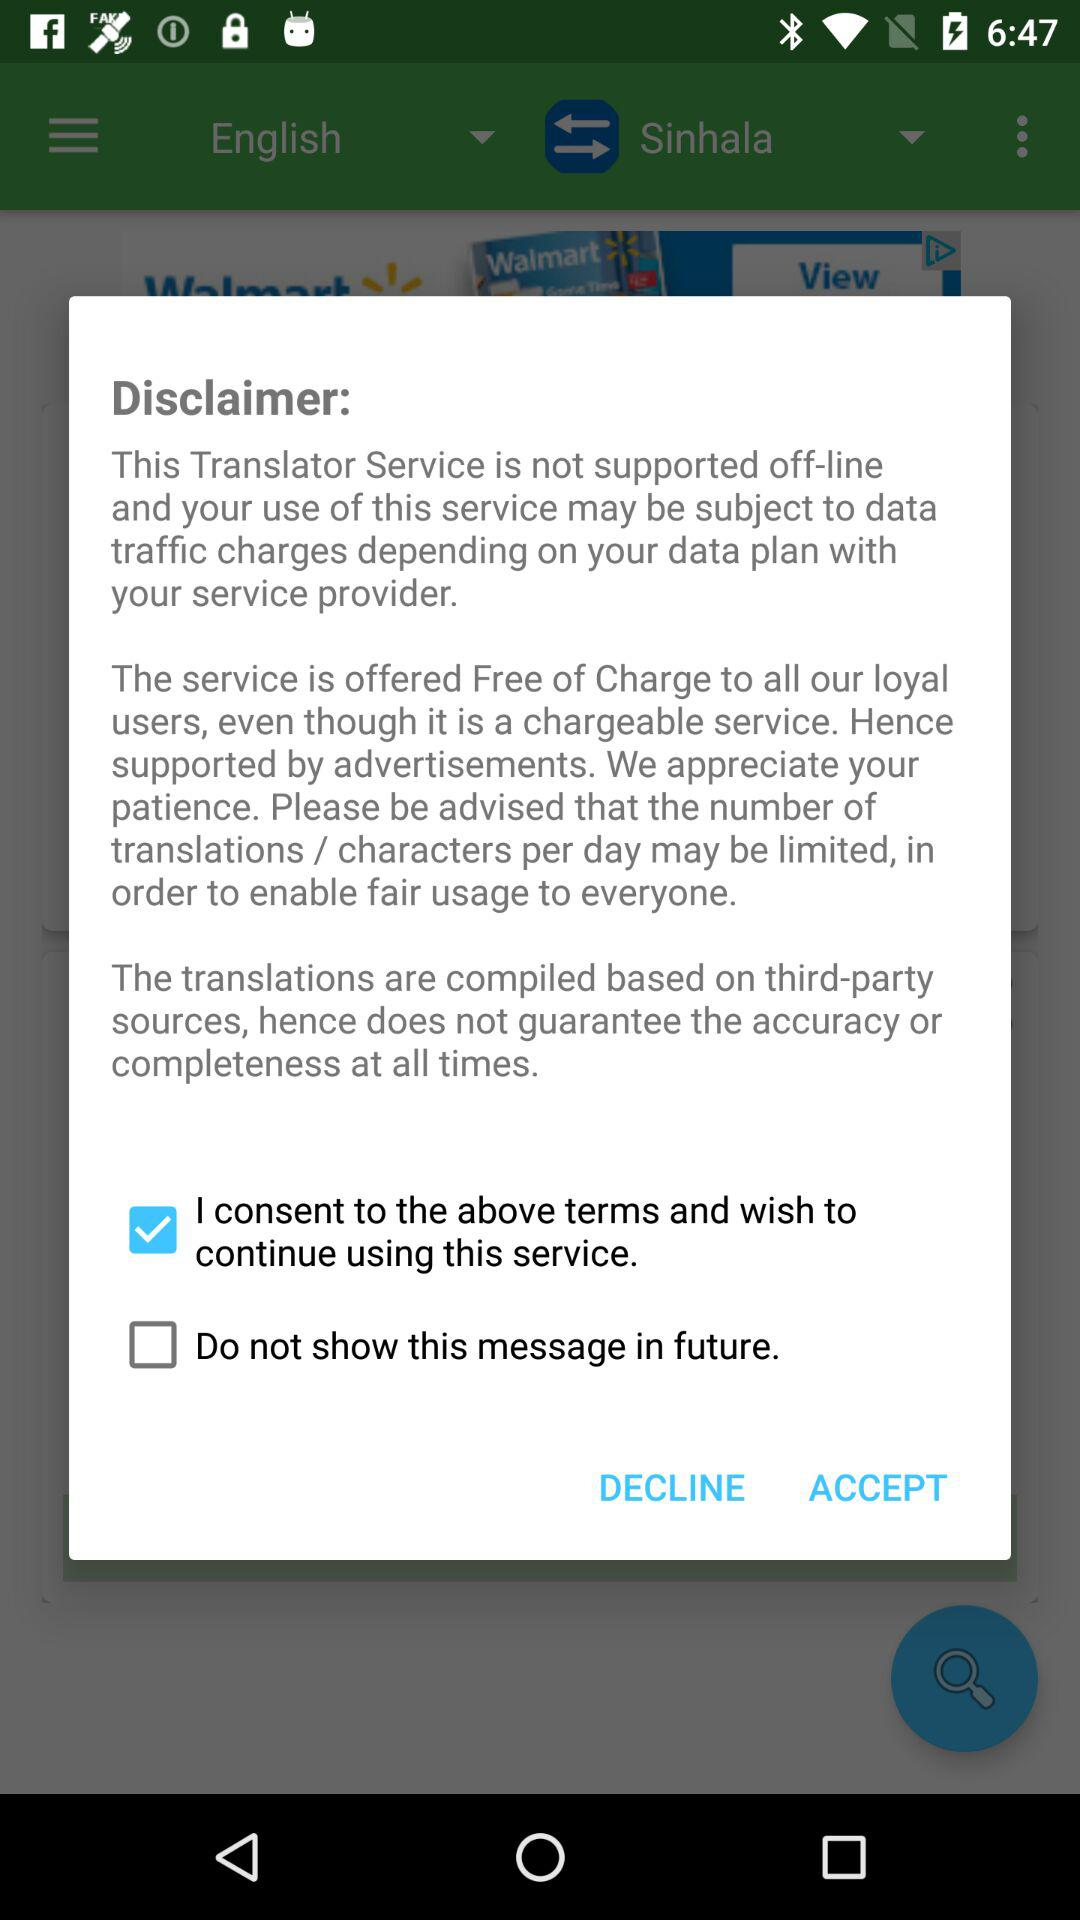How many disclaimer texts are there on the screen?
Answer the question using a single word or phrase. 3 